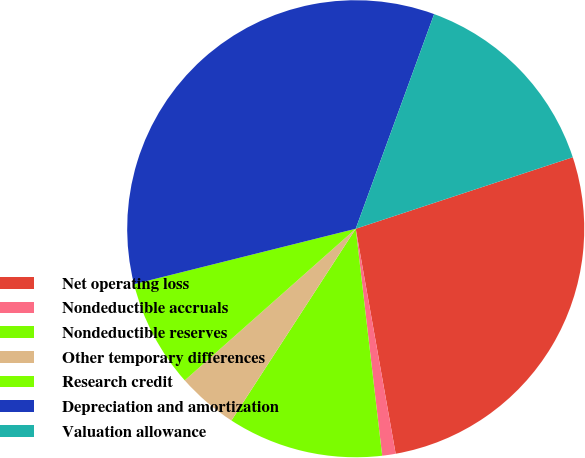Convert chart to OTSL. <chart><loc_0><loc_0><loc_500><loc_500><pie_chart><fcel>Net operating loss<fcel>Nondeductible accruals<fcel>Nondeductible reserves<fcel>Other temporary differences<fcel>Research credit<fcel>Depreciation and amortization<fcel>Valuation allowance<nl><fcel>27.27%<fcel>0.95%<fcel>11.0%<fcel>4.3%<fcel>7.65%<fcel>34.47%<fcel>14.36%<nl></chart> 